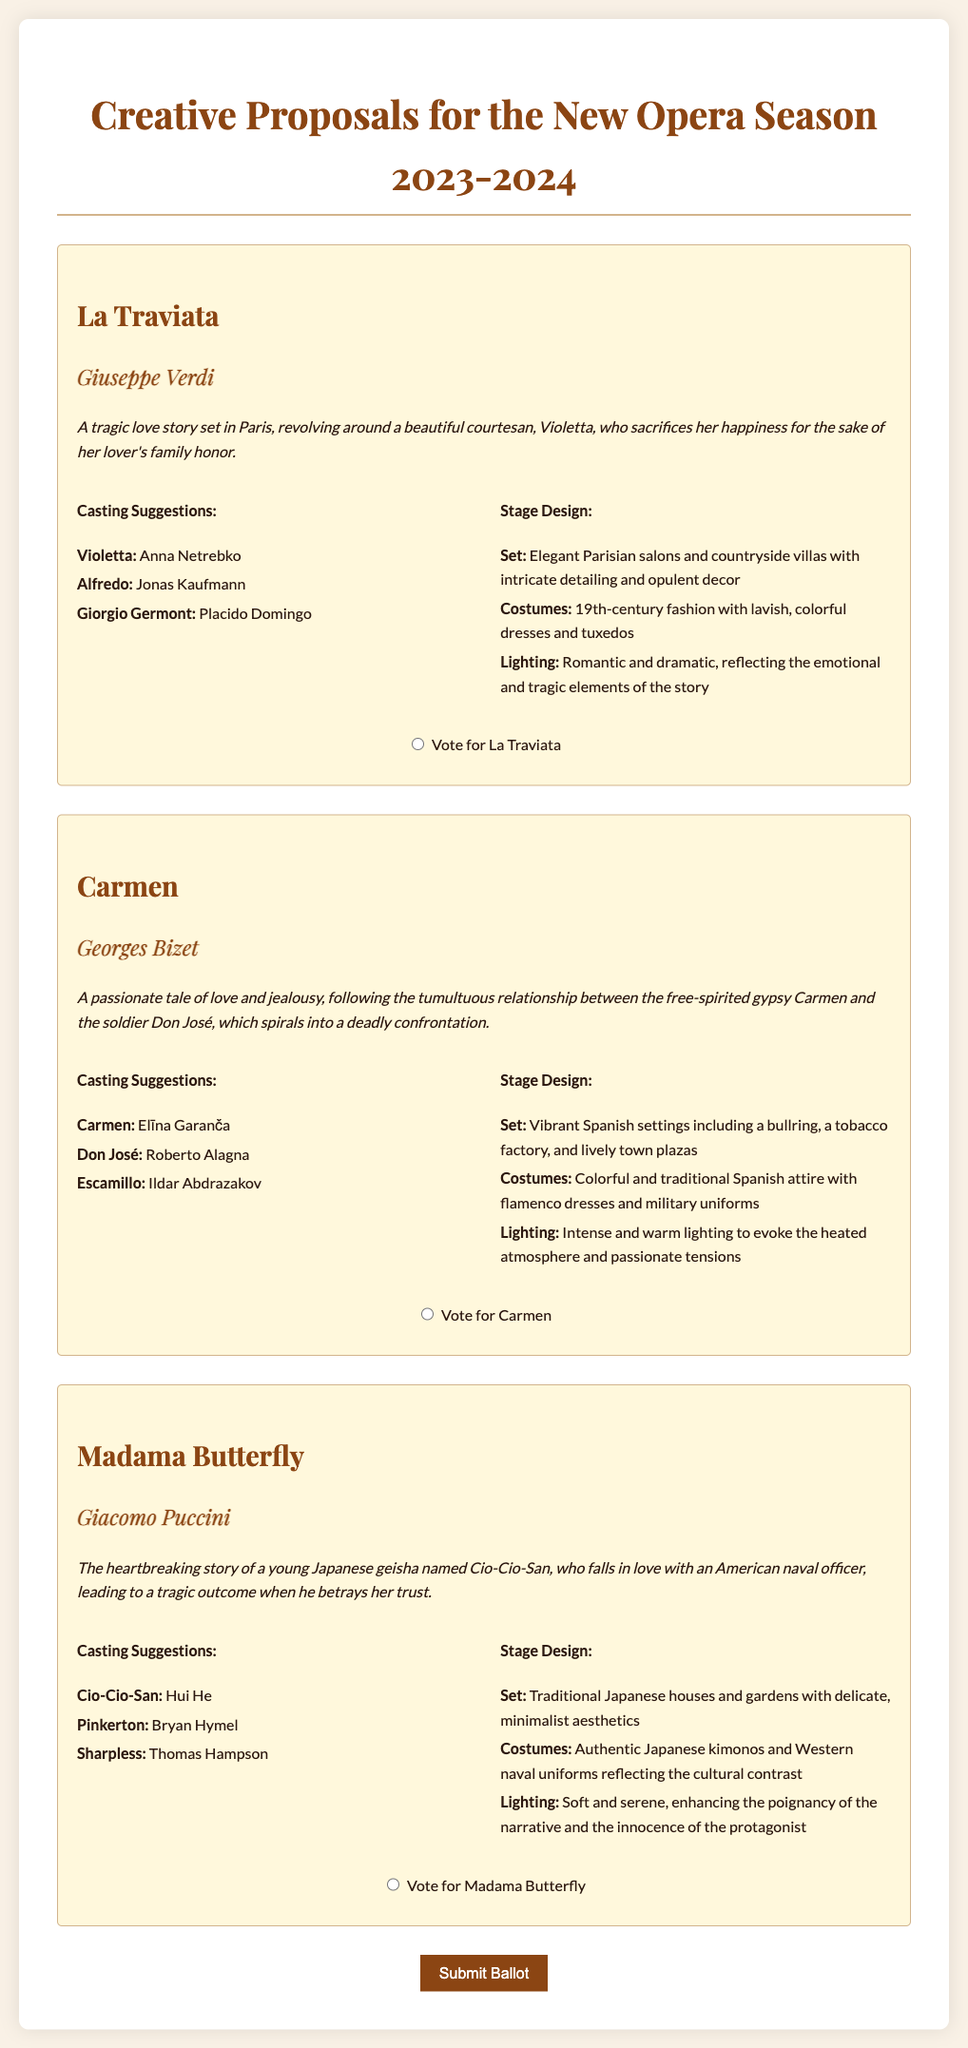What is the title of the first production? The title of the first production listed in the document is found in the first production section.
Answer: La Traviata Who composed Carmen? Carmen's composer is mentioned under the title of the production within the document.
Answer: Georges Bizet Who is suggested to play Violetta? The casting suggestions for Violetta can be found in the La Traviata section, indicating the suggested performer.
Answer: Anna Netrebko What type of settings are suggested for Carmen's stage design? The stage design for Carmen includes specific types of settings, listed in the stage design section of the production.
Answer: Vibrant Spanish settings How many productions are listed in the ballot? The total number of productions is determined by counting each production section in the document.
Answer: Three What is the relationship between Cio-Cio-San and Pinkerton? The synopsis for Madama Butterfly explains the relationship between these two characters, which is crucial to the plot.
Answer: Romantic What is the main theme of Madama Butterfly? The theme of Madama Butterfly is presented in its synopsis, providing a concise overview of the story.
Answer: Heartbreaking love What is the color theme of the lighting for La Traviata? The lighting description for La Traviata indicates the emotional style conveyed through color, found in the stage design section.
Answer: Romantic and dramatic Vote for which opera is the last production listed? The last production listed includes a specific voting option at the end of its section in the ballot.
Answer: Madama Butterfly 